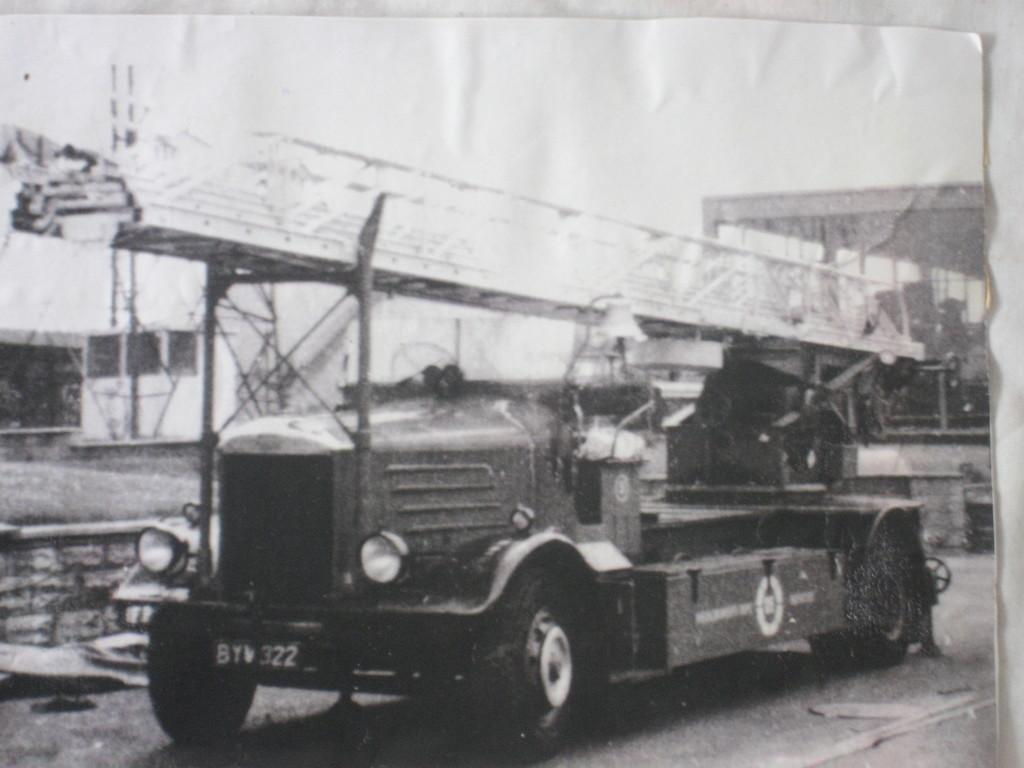What type of photograph is shown in the image? The image is a black and white photograph. What is the main subject of the photograph? The photograph contains pictures of a motor vehicle and iron grills. What can be seen on the ground in the photograph? The ground is visible in the photograph. What is visible in the background of the photograph? The sky is visible in the photograph. What type of hook is attached to the motor vehicle in the image? There is no hook visible on the motor vehicle in the image. What sound does the alarm make in the image? There is no alarm present in the image. 